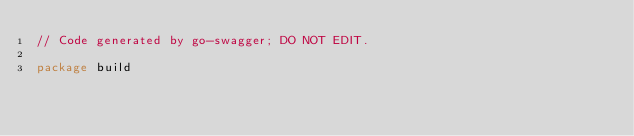Convert code to text. <code><loc_0><loc_0><loc_500><loc_500><_Go_>// Code generated by go-swagger; DO NOT EDIT.

package build
</code> 